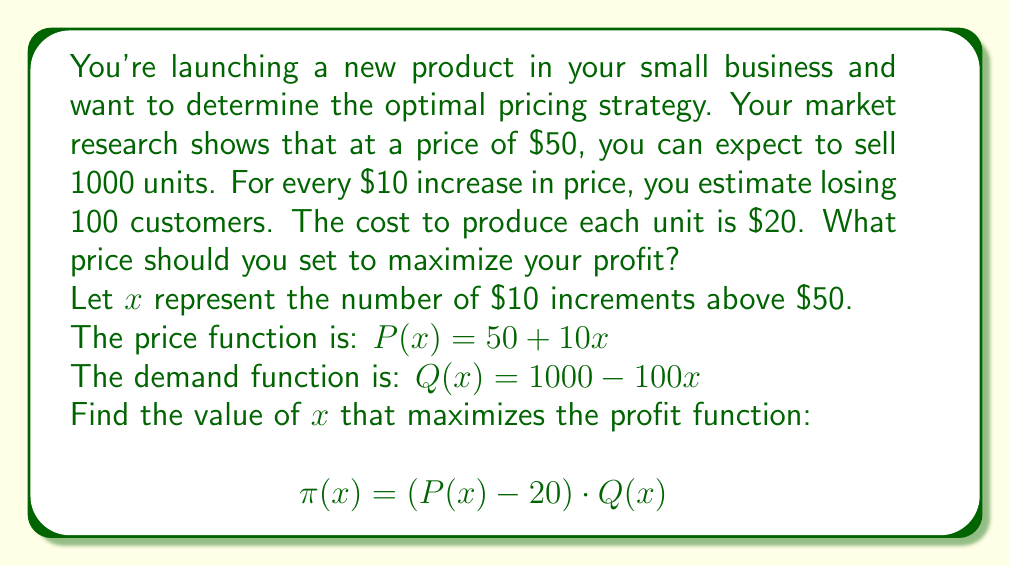Help me with this question. Let's approach this step-by-step:

1) First, let's expand our profit function:
   $$\pi(x) = (P(x) - 20) \cdot Q(x)$$
   $$\pi(x) = ((50 + 10x) - 20) \cdot (1000 - 100x)$$
   $$\pi(x) = (30 + 10x) \cdot (1000 - 100x)$$

2) Multiply out the terms:
   $$\pi(x) = 30000 - 3000x + 10000x - 1000x^2$$
   $$\pi(x) = 30000 + 7000x - 1000x^2$$

3) To find the maximum profit, we need to find where the derivative of this function equals zero:
   $$\frac{d\pi}{dx} = 7000 - 2000x$$

4) Set this equal to zero and solve for x:
   $$7000 - 2000x = 0$$
   $$-2000x = -7000$$
   $$x = 3.5$$

5) To confirm this is a maximum (not a minimum), check that the second derivative is negative:
   $$\frac{d^2\pi}{dx^2} = -2000$$ (which is indeed negative)

6) Since x represents $10 increments, 3.5 increments means we should increase the price by $35 from the initial $50.

7) Therefore, the optimal price is $50 + $35 = $85.
Answer: The optimal price to maximize profit is $85. 